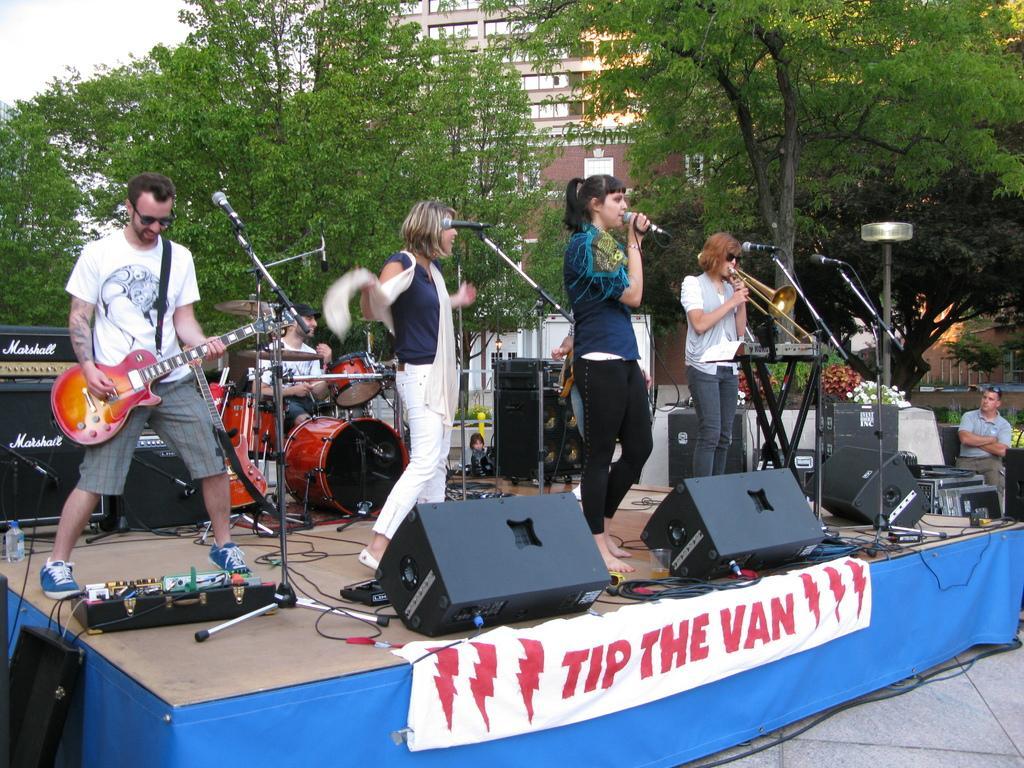Please provide a concise description of this image. This picture is clicked outside. In the center we can see the group of people standing and we can see the two persons standing and playing the musical instruments and we can see a person standing, holding a microphone and seems to be singing. On the right we can see a person and in the background we can see the sky, trees, buildings, musical instruments, speakers and many other objects and we can see a person seems to be sitting. 